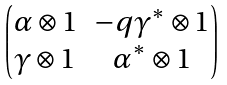Convert formula to latex. <formula><loc_0><loc_0><loc_500><loc_500>\begin{pmatrix} \alpha \otimes 1 & - q \gamma ^ { * } \otimes 1 \\ \gamma \otimes 1 & \alpha ^ { * } \otimes 1 \end{pmatrix}</formula> 